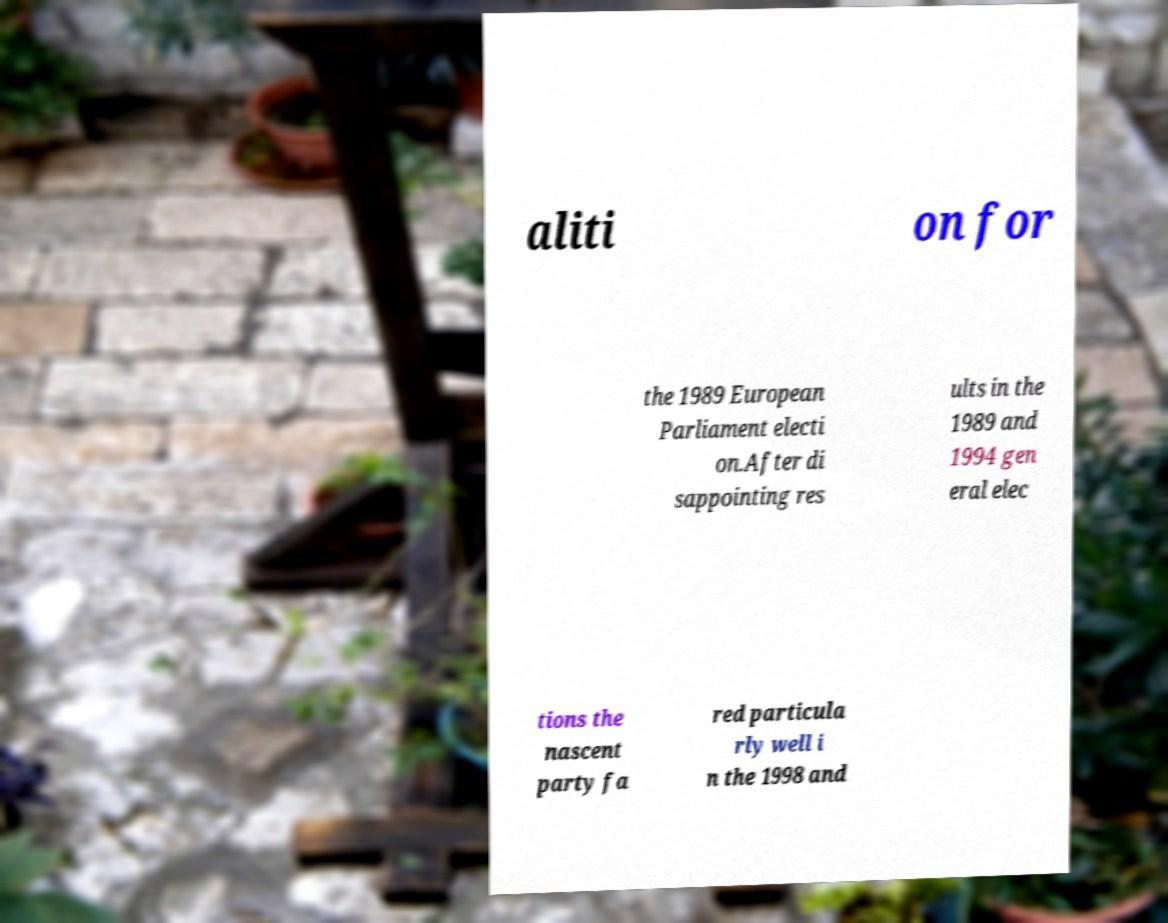There's text embedded in this image that I need extracted. Can you transcribe it verbatim? aliti on for the 1989 European Parliament electi on.After di sappointing res ults in the 1989 and 1994 gen eral elec tions the nascent party fa red particula rly well i n the 1998 and 